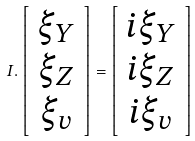<formula> <loc_0><loc_0><loc_500><loc_500>I . \left [ \begin{array} { c } \xi _ { Y } \\ \xi _ { Z } \\ \xi _ { v } \end{array} \right ] = \left [ \begin{array} { c } i \xi _ { Y } \\ i \xi _ { Z } \\ i \xi _ { v } \end{array} \right ]</formula> 